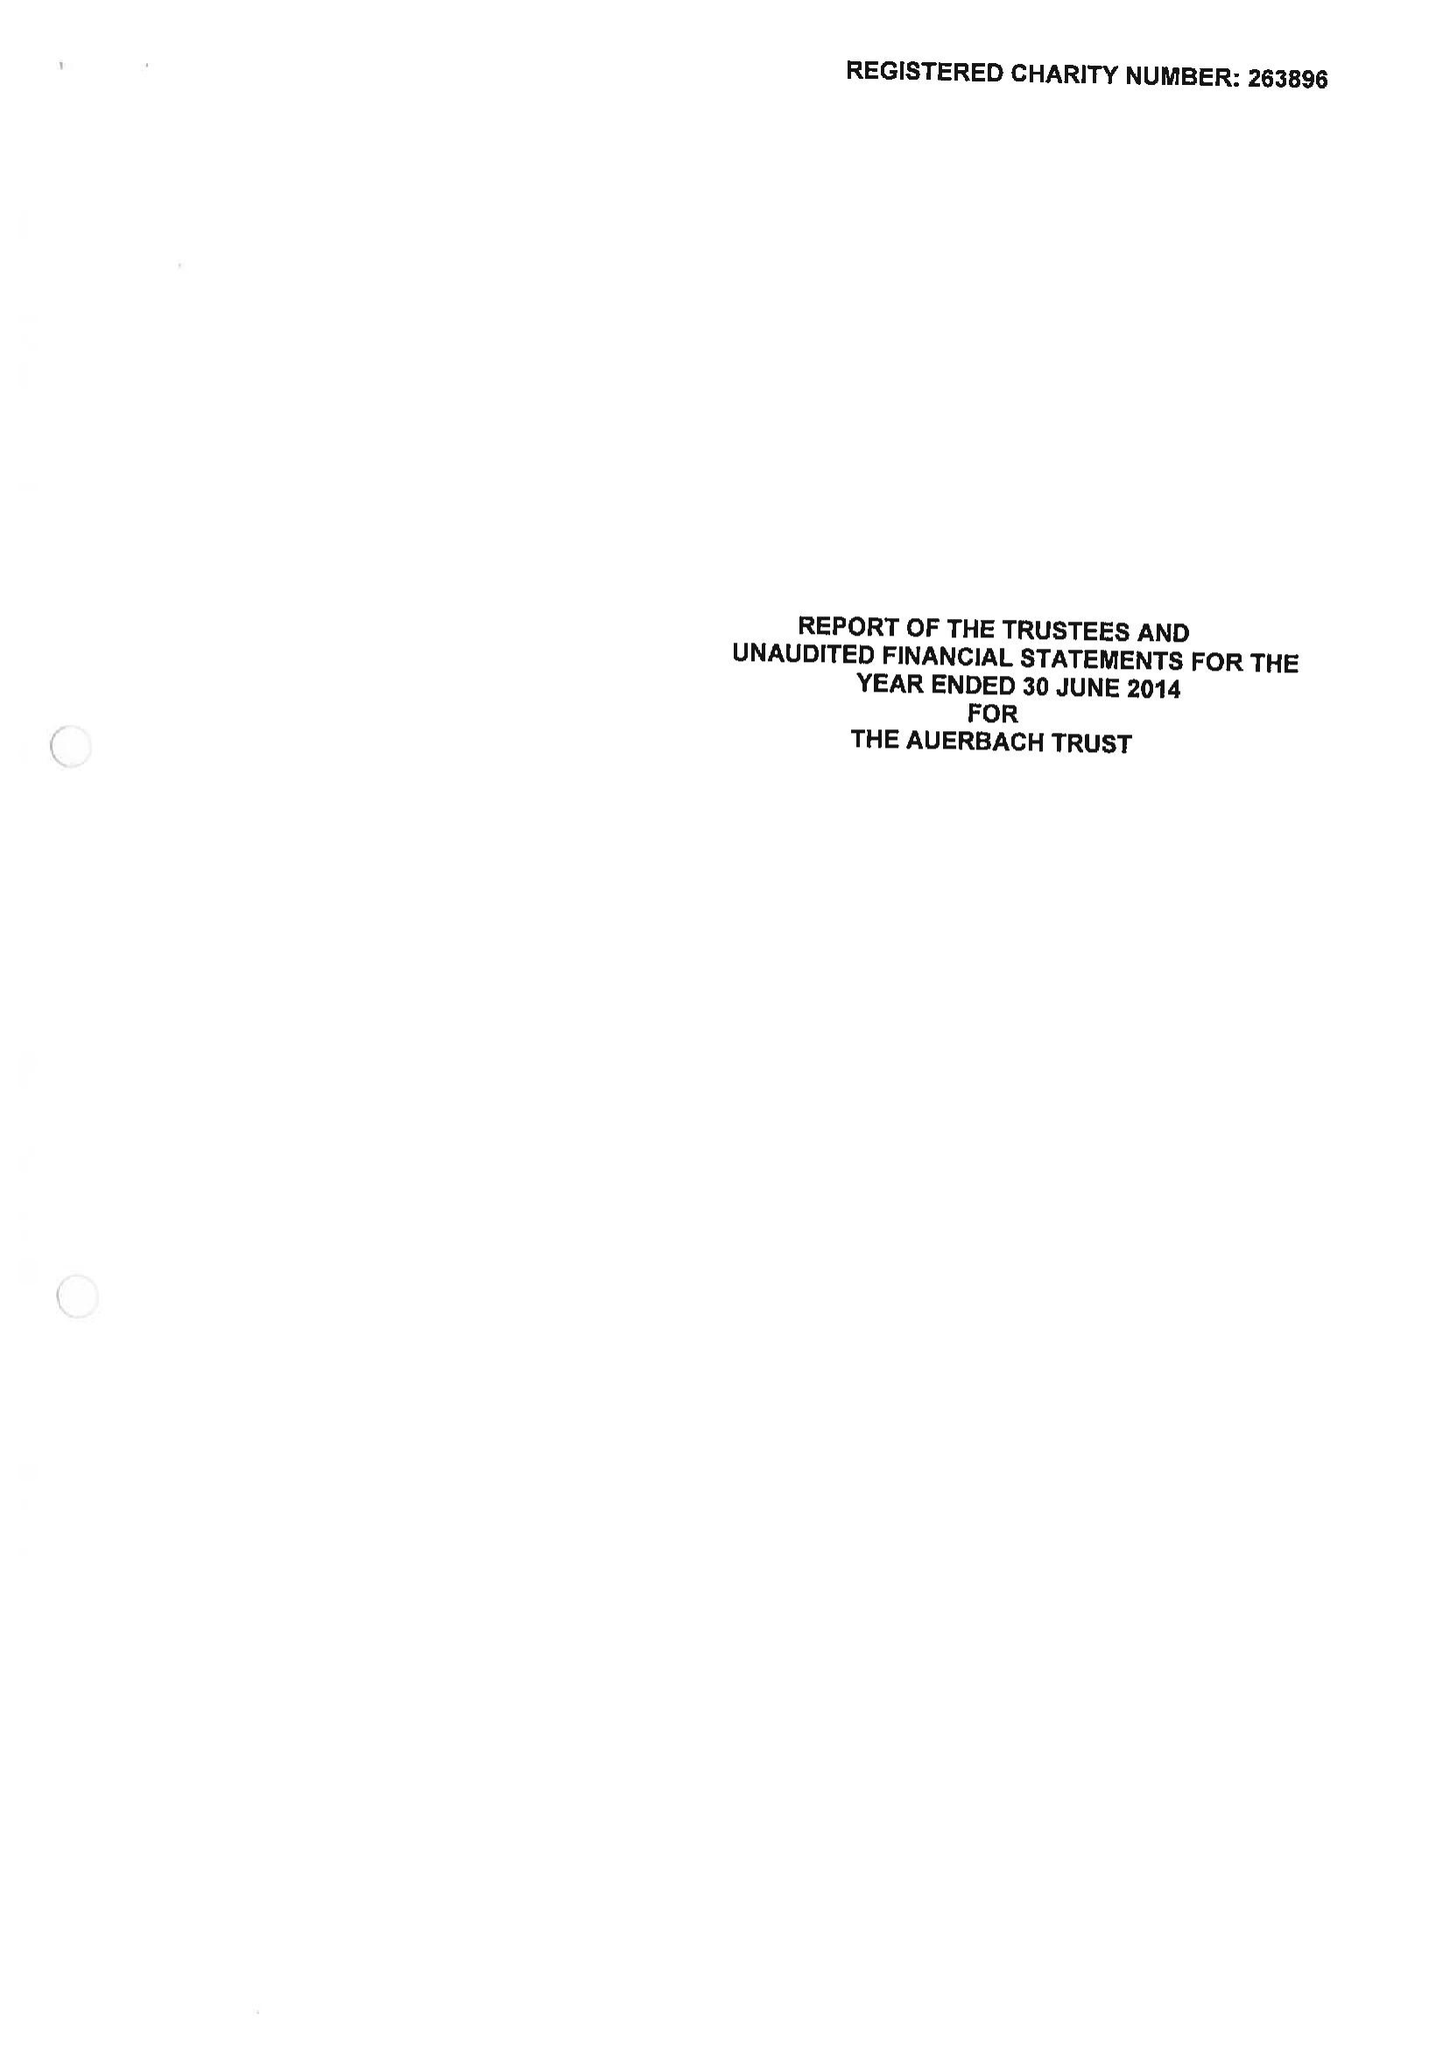What is the value for the address__post_town?
Answer the question using a single word or phrase. LONDON 